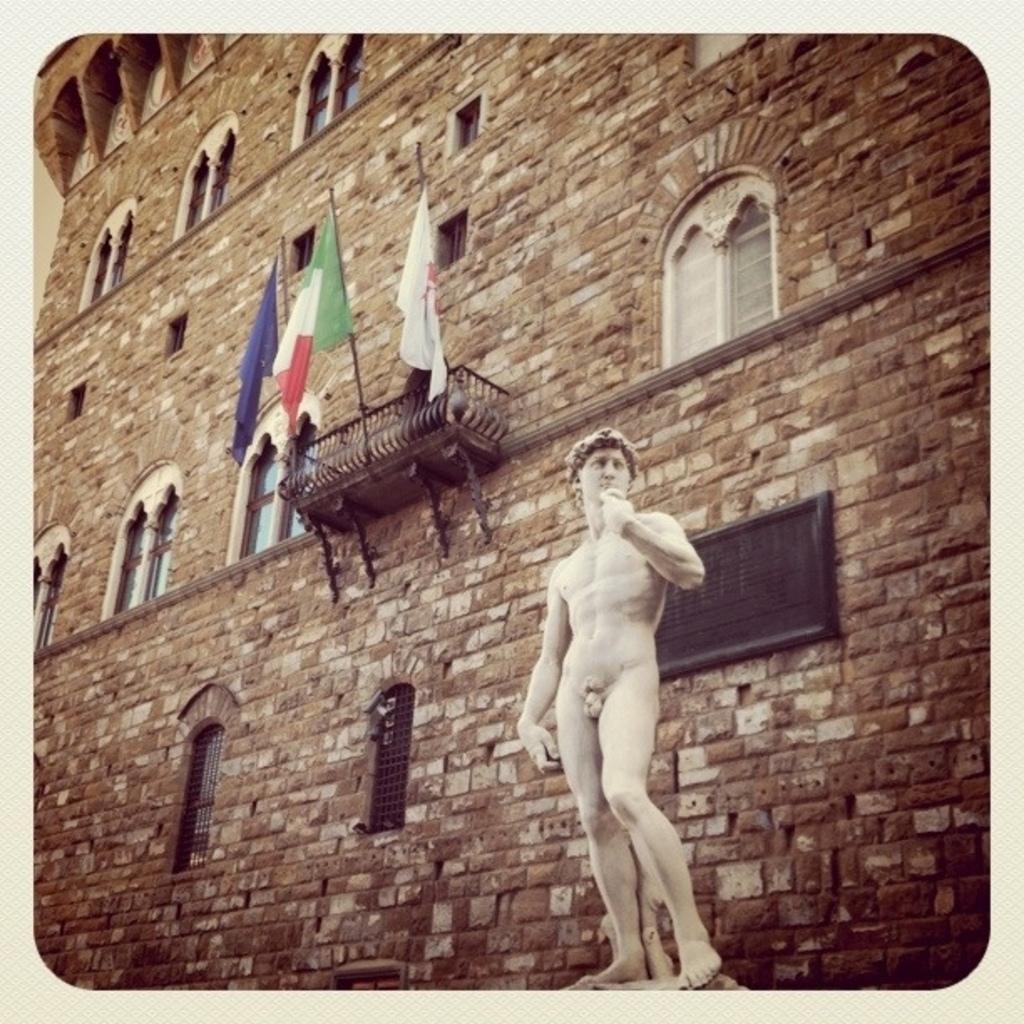Please provide a concise description of this image. In this picture we can see a statue in the front, in the background there is a building, we can see three flags, we can also see windows of the building. 